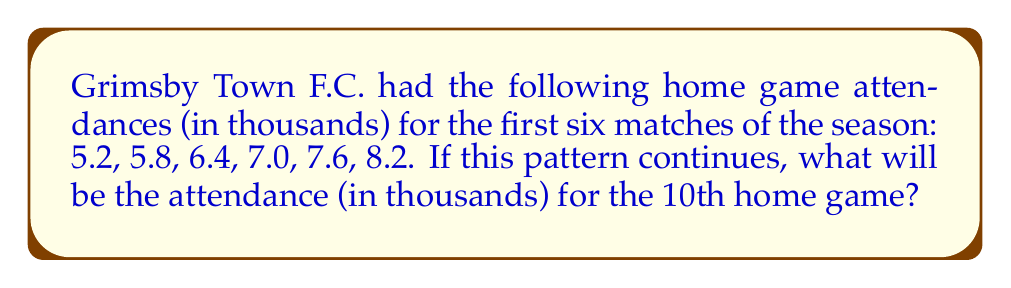Give your solution to this math problem. Let's approach this step-by-step:

1) First, we need to identify the pattern in the given sequence:
   5.2, 5.8, 6.4, 7.0, 7.6, 8.2

2) To find the pattern, let's calculate the difference between each consecutive term:
   5.8 - 5.2 = 0.6
   6.4 - 5.8 = 0.6
   7.0 - 6.4 = 0.6
   7.6 - 7.0 = 0.6
   8.2 - 7.6 = 0.6

3) We can see that the difference is consistently 0.6. This means we have an arithmetic sequence with a common difference of 0.6.

4) The general formula for an arithmetic sequence is:
   $$a_n = a_1 + (n-1)d$$
   Where $a_n$ is the nth term, $a_1$ is the first term, $n$ is the position of the term, and $d$ is the common difference.

5) In our case:
   $a_1 = 5.2$ (first term)
   $d = 0.6$ (common difference)
   We want to find $a_{10}$ (10th term)

6) Plugging these into our formula:
   $$a_{10} = 5.2 + (10-1)0.6$$
   $$a_{10} = 5.2 + 9(0.6)$$
   $$a_{10} = 5.2 + 5.4$$
   $$a_{10} = 10.6$$

Therefore, the attendance for the 10th home game will be 10.6 thousand.
Answer: 10.6 